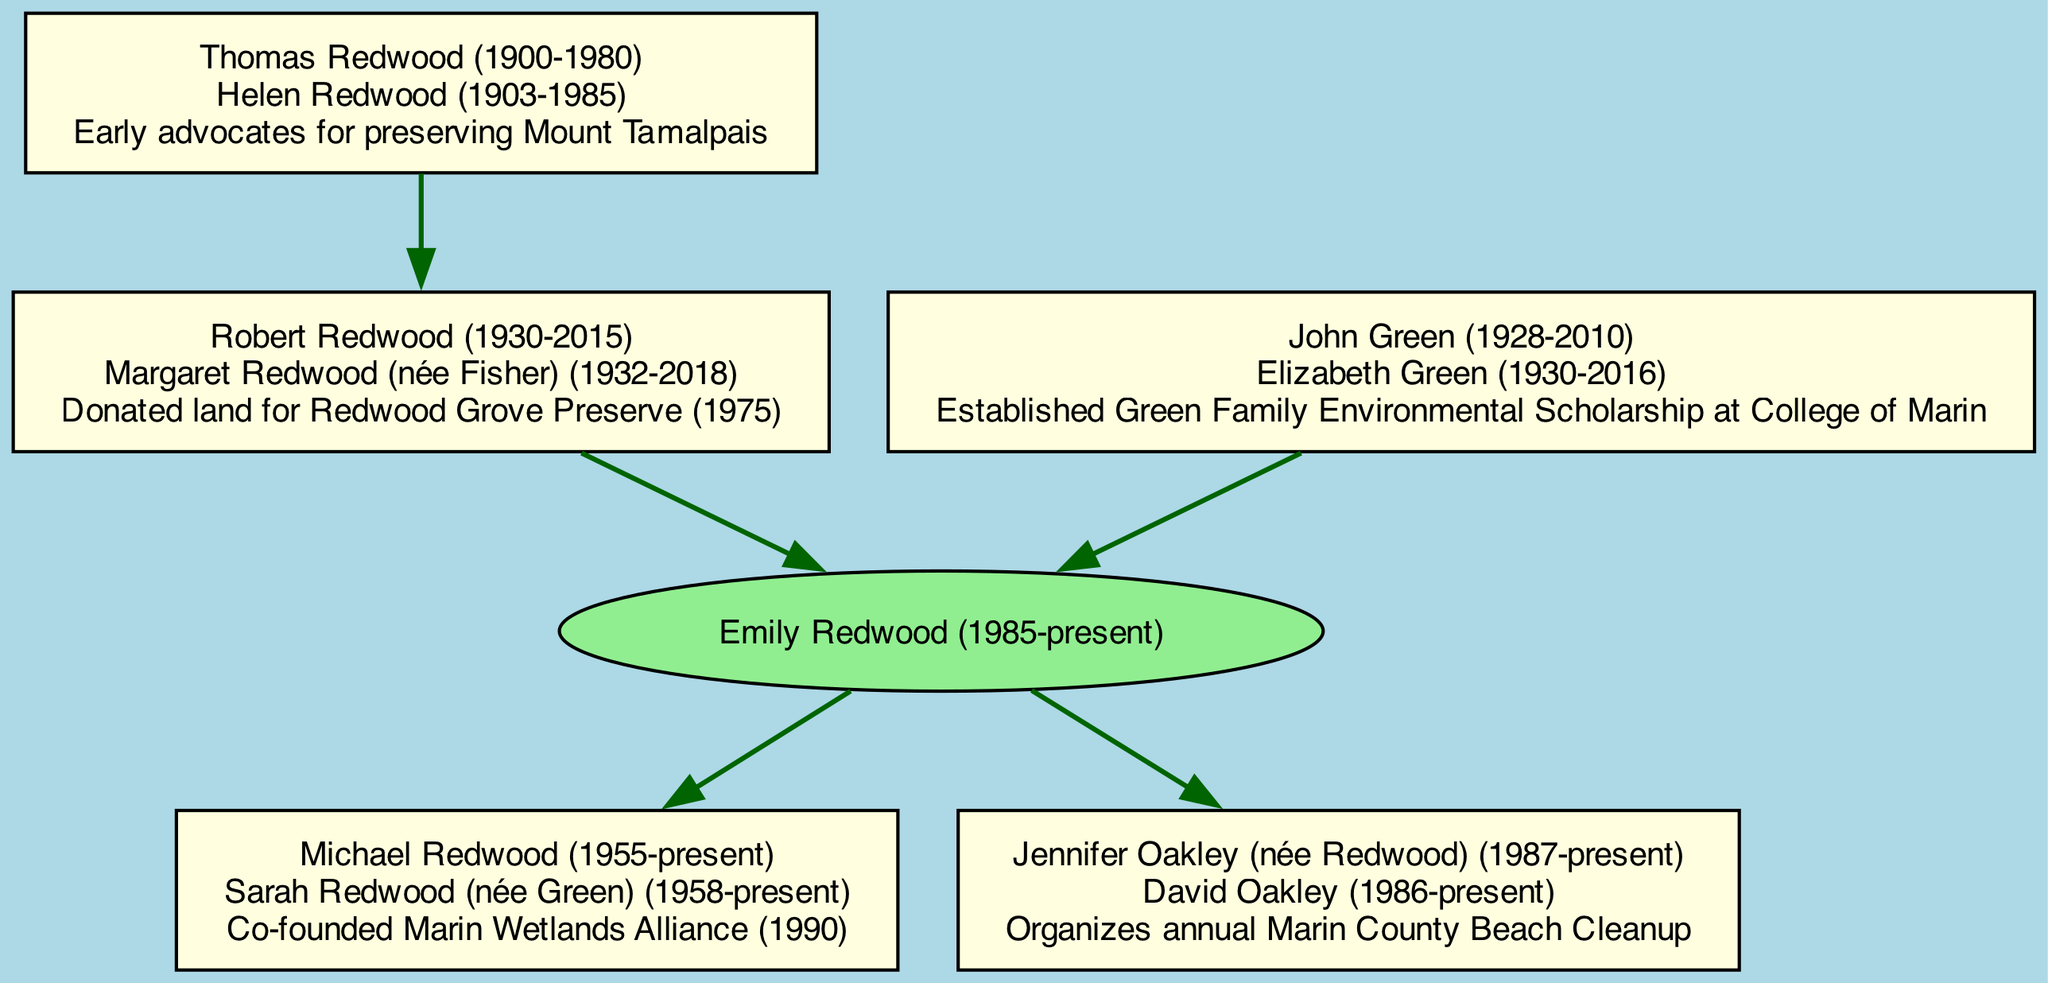What is the name of the family tree's root individual? The root of the family tree is labeled as "Emily Redwood (1985-present)." This is the primary ancestor from whom all other members of the family are descended.
Answer: Emily Redwood (1985-present) How many children does Emily Redwood have? The diagram indicates that Emily Redwood has two children listed, Michael Redwood and Jennifer Oakley. Therefore, I counted the child nodes connected to her.
Answer: 2 What significant conservation effort did Michael Redwood co-found? According to the diagram, Michael Redwood co-founded the "Marin Wetlands Alliance" in 1990. This is explicitly mentioned in his node details.
Answer: Marin Wetlands Alliance (1990) What is the connection to conservation efforts mentioned for John Green? The node for John Green details that he established the "Green Family Environmental Scholarship at College of Marin." Therefore, combining his name with the conservation effort leads to the answer.
Answer: Established Green Family Environmental Scholarship at College of Marin How many total grandparents are represented in the family tree? The diagram shows two grandparents connected to the root individual, Emily Redwood. This count includes both Robert and John Green, which I verified through the grandparent nodes.
Answer: 2 Which great-grandparent's connection involves advocating for a specific geographical feature? The node for Thomas Redwood indicates that he and his spouse were known as "Early advocates for preserving Mount Tamalpais." This information directly relates to the preservation of the mountain.
Answer: Mount Tamalpais Who organized the annual Marin County Beach Cleanup? In the diagram, it is stated that Jennifer Oakley is involved in organizing the "annual Marin County Beach Cleanup." I confirmed this by reviewing the text in her node.
Answer: Organizes annual Marin County Beach Cleanup What is the relationship between Robert Redwood and Emily Redwood? Robert Redwood is listed as the father of Emily Redwood. As he is connected to her in the family tree as one of her grandparents, this is the determining factor.
Answer: Grandfather What year did Robert Redwood donate land for conservation? The diagram indicates that Robert Redwood donated land for the Redwood Grove Preserve in 1975, which is explicitly mentioned in his node details.
Answer: 1975 